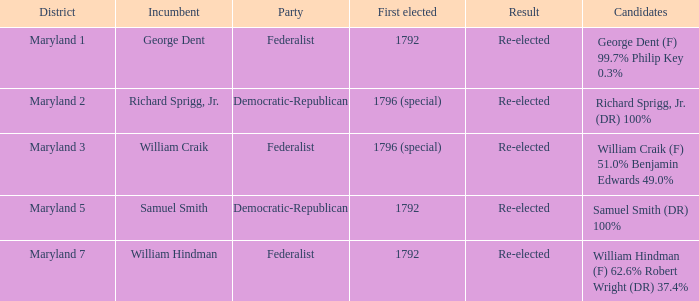Which political party does samuel smith represent as the current officeholder? Democratic-Republican. 